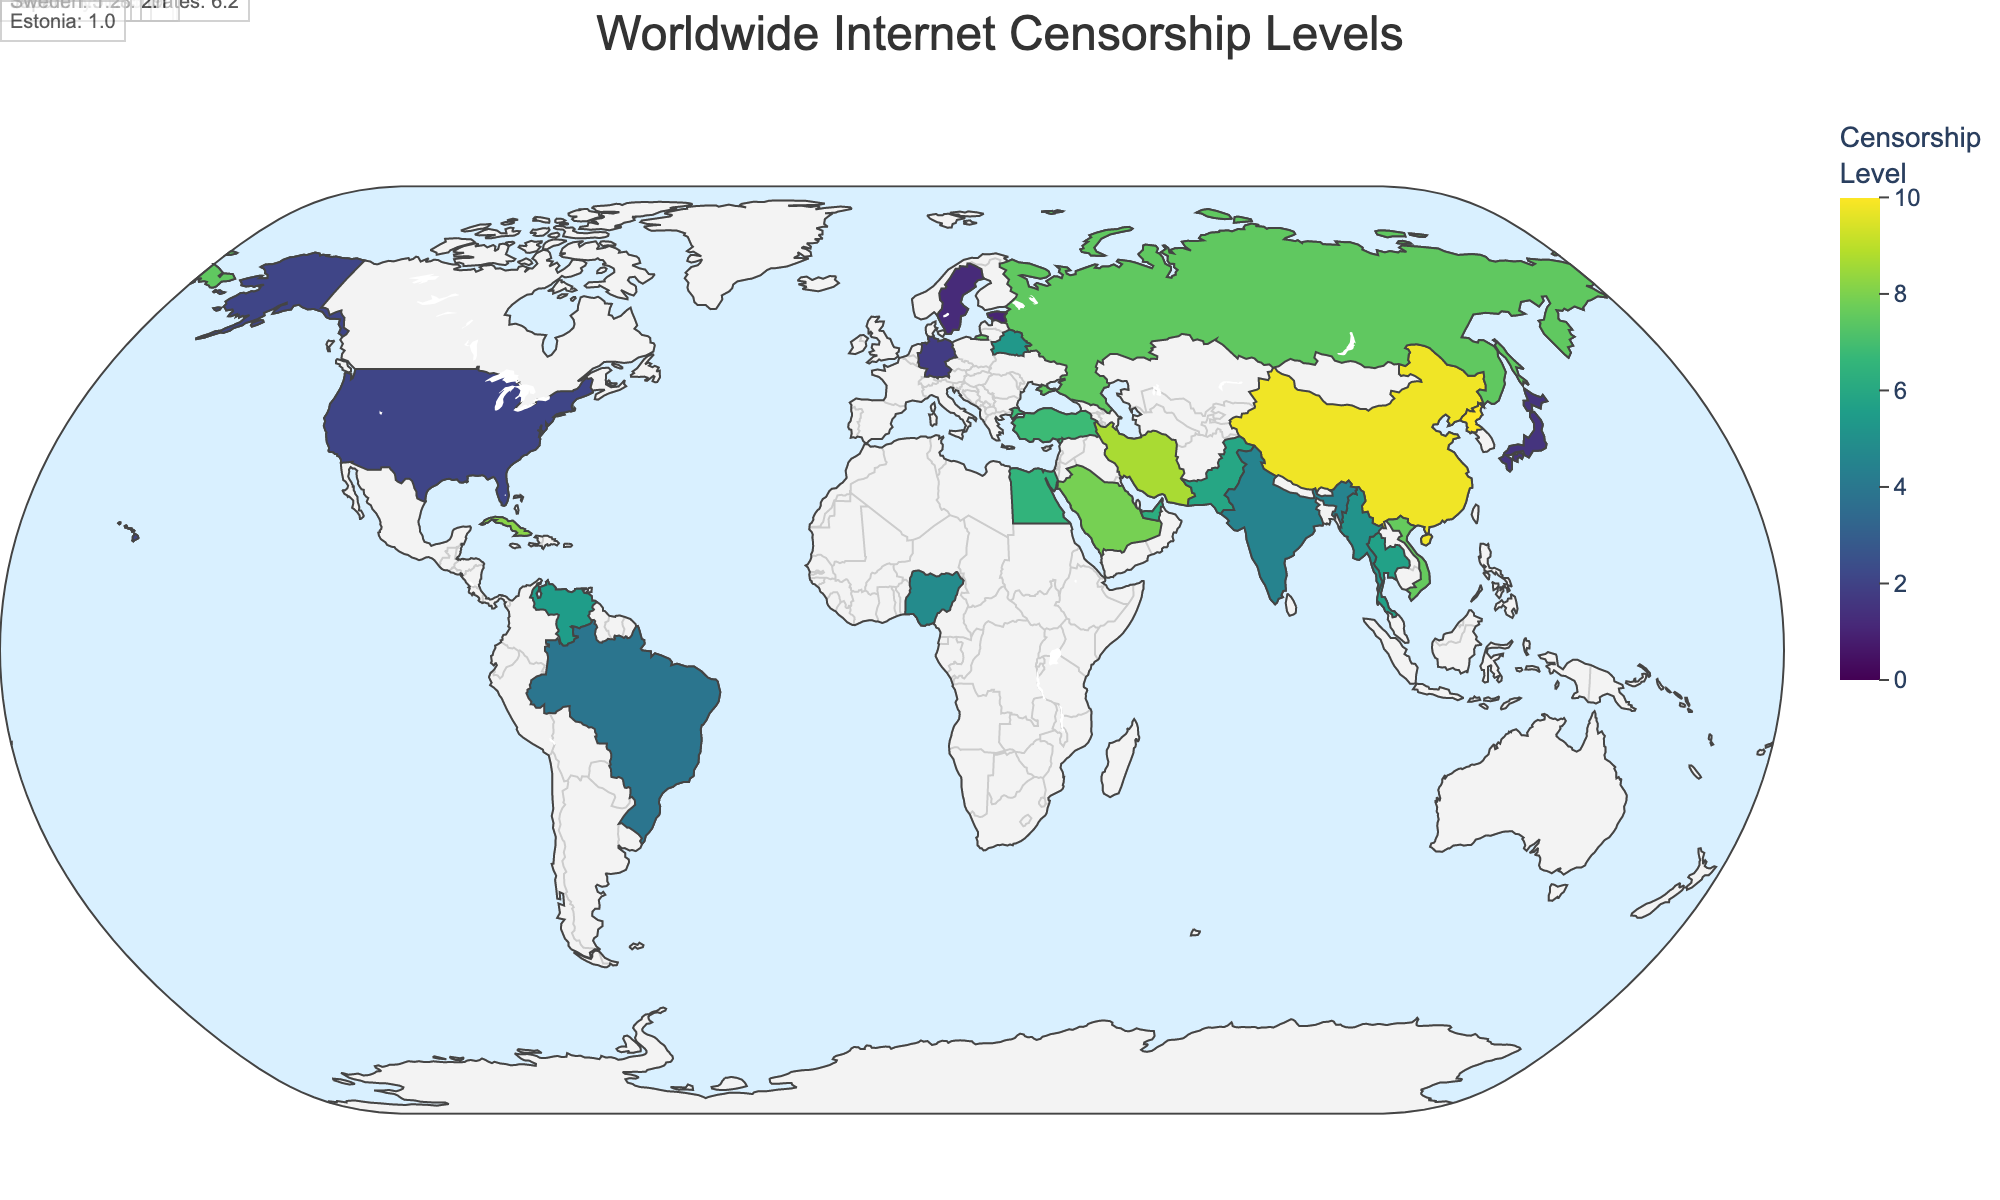What is the highest censorship level shown on the map? The highest level of censorship visible on the map can be identified by looking for the darkest colored regions correlating with the highest values on the color scale. North Korea is shown with the highest value.
Answer: 10.0 What regions have countries with censorship levels above 8? To answer this, identify the countries with censorship levels above 8 and note their corresponding regions. These countries are China (Asia), North Korea (Asia), Iran (Middle East), Saudi Arabia (Middle East), and Cuba (Caribbean).
Answer: Asia, Middle East, Caribbean Which country in Europe has the highest internet censorship level? The highest censorship level among European countries can be found by comparing the values of each European country on the map. Russia shows the highest censorship level within Europe.
Answer: Russia What is the average censorship level of Southeast Asian countries in the dataset? To find this, first isolate the Southeast Asian countries (Vietnam, Thailand, Myanmar) and their censorship levels: 7.6, 5.7, and 5.1, respectively. Then calculate the average by summing these values and dividing by the number of countries. Average = (7.6 + 5.7 + 5.1)/3 = 18.4/3 = 6.13.
Answer: 6.13 Which country has a lower censorship level: Brazil or Venezuela? Compare the censorship levels of Brazil and Venezuela shown on the map. Brazil has a censorship level of 3.9, whereas Venezuela has a censorship level of 5.5.
Answer: Brazil Are there any countries with a censorship level below 2? Examine the countries on the map to find any with a censorship level below 2. Estonia, Sweden, and Japan have censorship levels of 1.0, 1.2, and 1.5 respectively.
Answer: Yes Which continent shows the most variation in censorship levels among its countries? Identify continents with multiple countries in the dataset, then compare the range (difference between highest and lowest values) in censorship levels for these continents. Europe ranges from Estonia (1.0) to Russia (7.5), showing the largest variation.
Answer: Europe What are the censorship levels for the countries located in North America? Look at the countries in North America and identify their censorship levels from the map. The United States has a censorship level of 2.1.
Answer: 2.1 How does the censorship level of Nigeria compare to that of Egypt? Compare the censorship levels of Nigeria and Egypt shown on the map. Nigeria has a level of 4.8, and Egypt has a level of 6.5.
Answer: Nigeria has a lower level What is the range of censorship levels for the countries in the Middle East listed in the dataset? Identify the countries in the Middle East and their censorship levels: Iran (8.7), Saudi Arabia (7.9), Turkey (6.8), United Arab Emirates (6.2). The range is the difference between the highest and lowest values, which is 8.7 - 6.2 = 2.5.
Answer: 2.5 